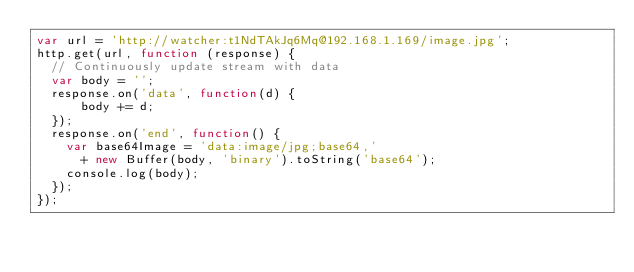Convert code to text. <code><loc_0><loc_0><loc_500><loc_500><_JavaScript_>var url = 'http://watcher:t1NdTAkJq6Mq@192.168.1.169/image.jpg';
http.get(url, function (response) {
  // Continuously update stream with data
  var body = '';
  response.on('data', function(d) {
      body += d;
  });
  response.on('end', function() {
    var base64Image = 'data:image/jpg;base64,'
      + new Buffer(body, 'binary').toString('base64');
    console.log(body);
  });
});
</code> 